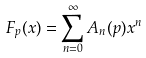Convert formula to latex. <formula><loc_0><loc_0><loc_500><loc_500>F _ { p } ( x ) = \sum _ { n = 0 } ^ { \infty } A _ { n } ( p ) x ^ { n }</formula> 